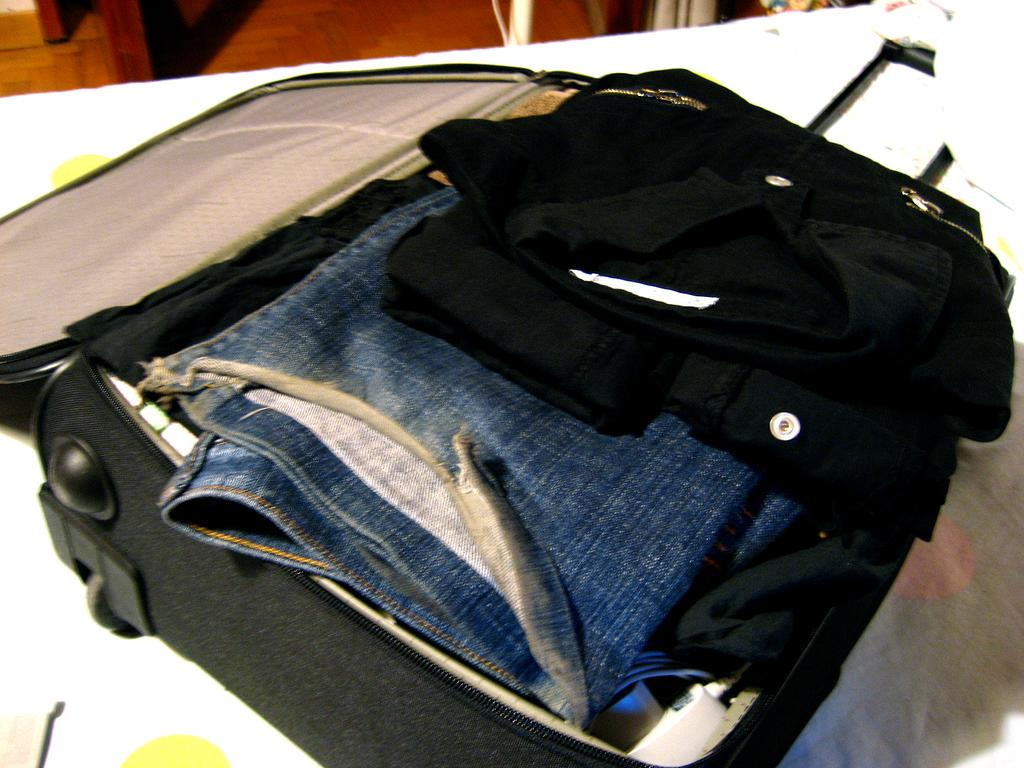What is inside the suitcase in the image? There are objects and clothes in the suitcase. On what surface is the suitcase placed? The suitcase is on a white color surface. What colors can be seen in the background of the image? The background of the image is in brown and cream colors. Can you see any giants interacting with the suitcase in the image? No, there are no giants present in the image. What type of zebra can be seen in the background of the image? There is no zebra present in the image; the background colors are brown and cream. 